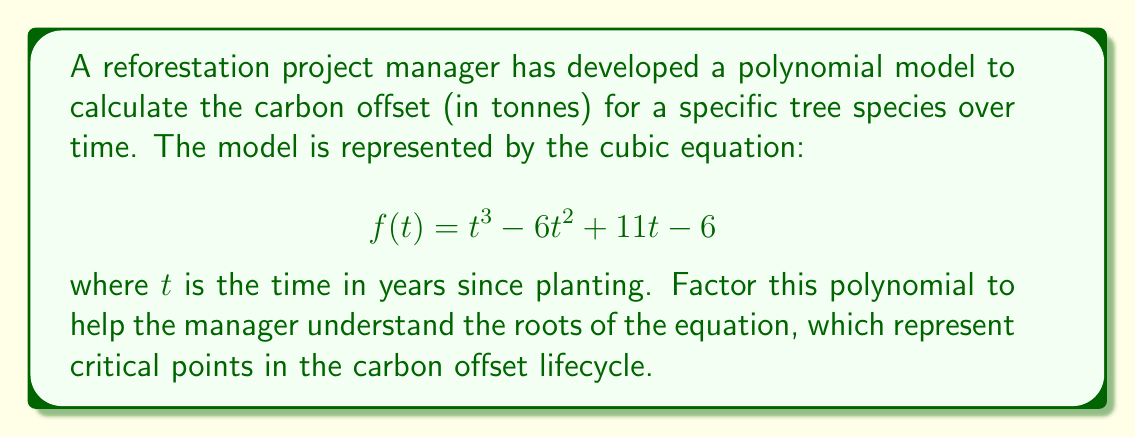Give your solution to this math problem. To factor this cubic polynomial, we'll follow these steps:

1) First, let's check if there's a rational root. We can use the rational root theorem to list possible roots: $\pm1, \pm2, \pm3, \pm6$

2) By testing these values, we find that $f(1) = 0$. So $(t-1)$ is a factor.

3) We can use polynomial long division to divide $f(t)$ by $(t-1)$:

   $$\frac{t^3 - 6t^2 + 11t - 6}{t-1} = t^2 - 5t + 6$$

4) Now we have: $f(t) = (t-1)(t^2 - 5t + 6)$

5) The quadratic factor $t^2 - 5t + 6$ can be factored further:
   
   $$t^2 - 5t + 6 = (t-2)(t-3)$$

6) Therefore, the complete factorization is:

   $$f(t) = (t-1)(t-2)(t-3)$$

This factorization shows that the roots of the equation are at $t=1$, $t=2$, and $t=3$, representing critical years in the carbon offset lifecycle of the trees.
Answer: $f(t) = (t-1)(t-2)(t-3)$ 